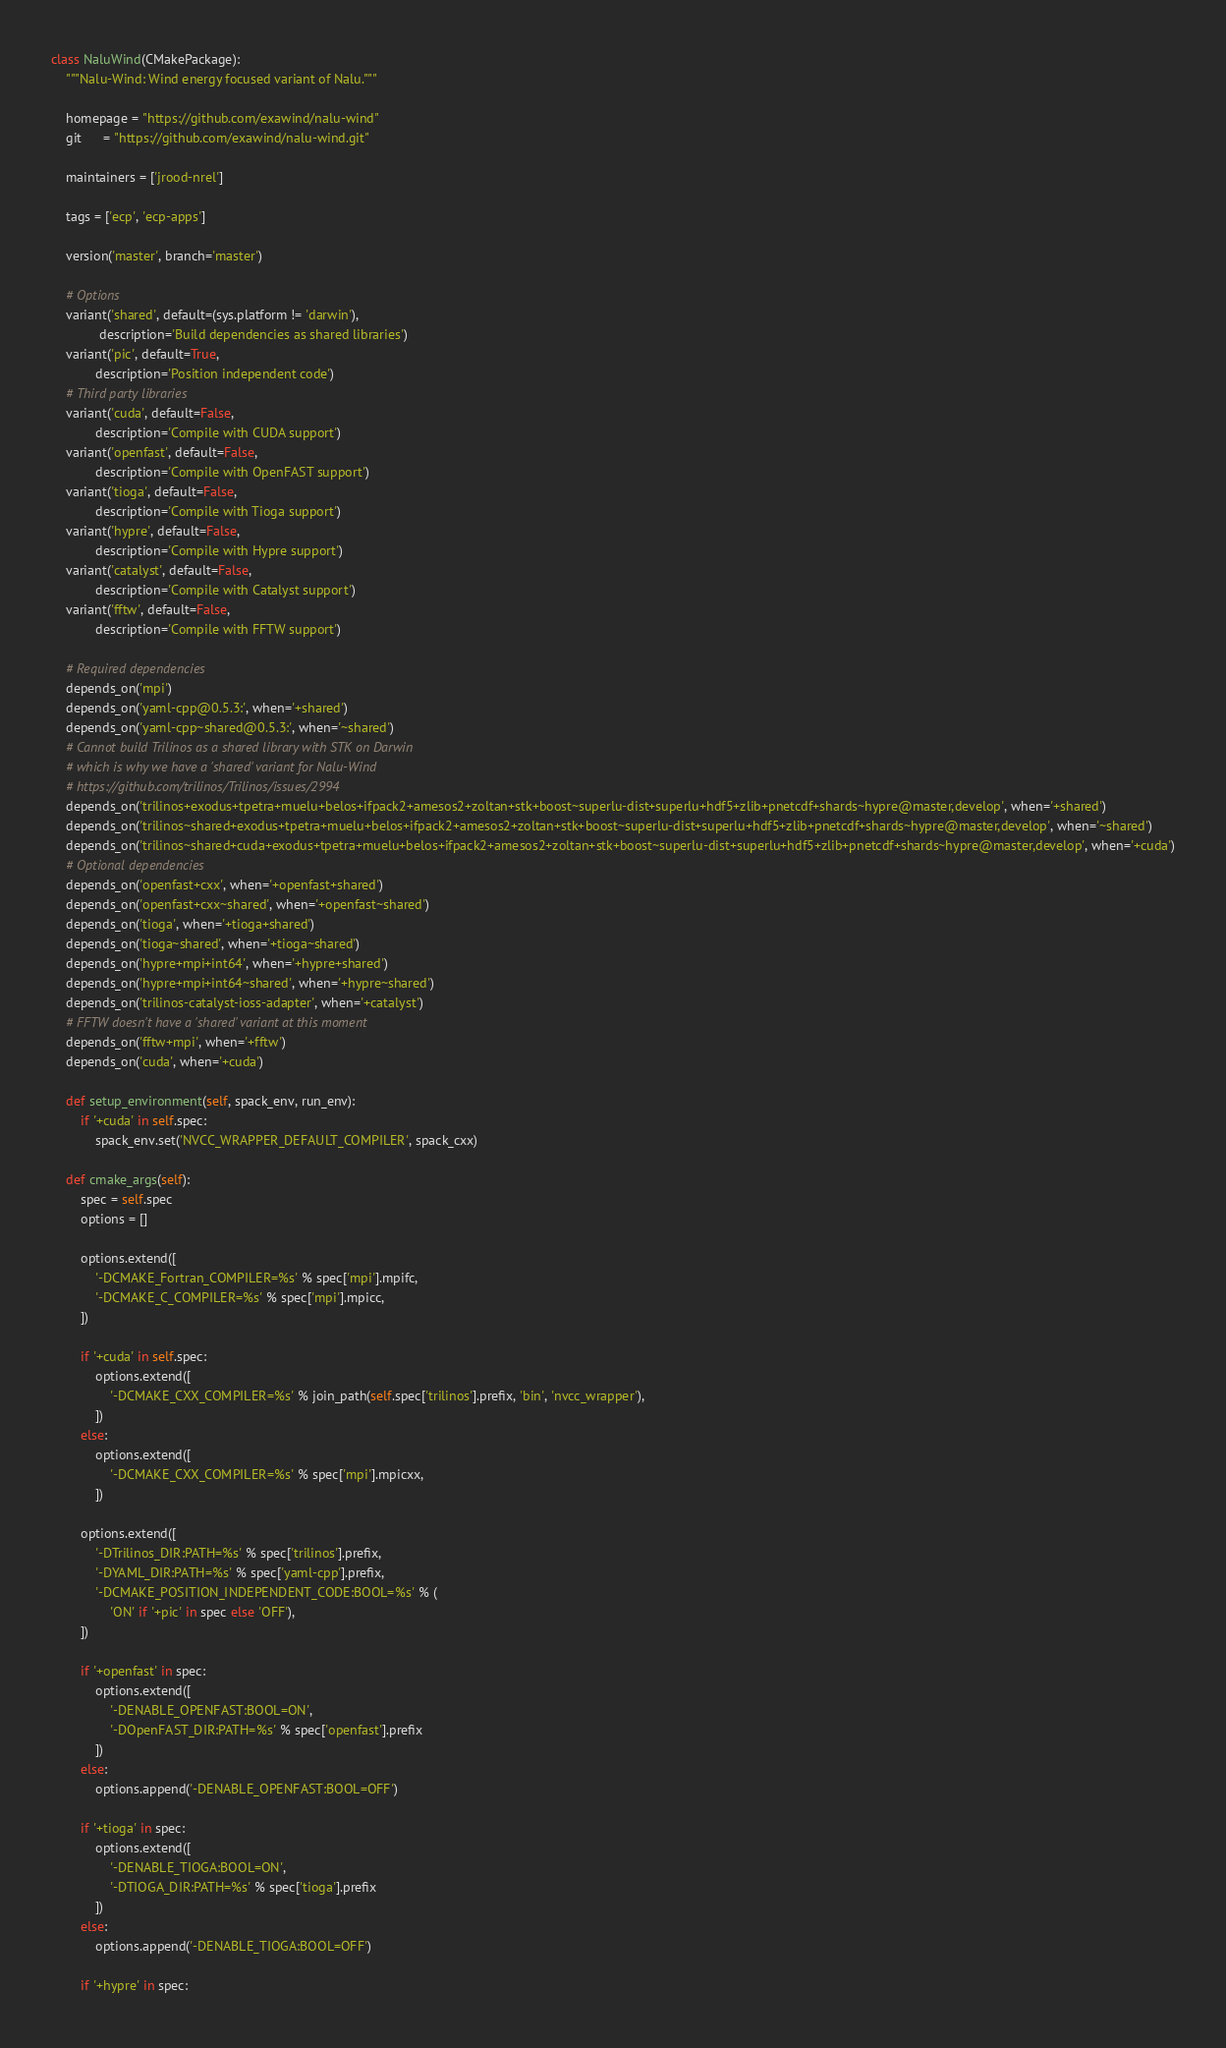<code> <loc_0><loc_0><loc_500><loc_500><_Python_>class NaluWind(CMakePackage):
    """Nalu-Wind: Wind energy focused variant of Nalu."""

    homepage = "https://github.com/exawind/nalu-wind"
    git      = "https://github.com/exawind/nalu-wind.git"

    maintainers = ['jrood-nrel']

    tags = ['ecp', 'ecp-apps']

    version('master', branch='master')

    # Options
    variant('shared', default=(sys.platform != 'darwin'),
             description='Build dependencies as shared libraries')
    variant('pic', default=True,
            description='Position independent code')
    # Third party libraries
    variant('cuda', default=False,
            description='Compile with CUDA support')
    variant('openfast', default=False,
            description='Compile with OpenFAST support')
    variant('tioga', default=False,
            description='Compile with Tioga support')
    variant('hypre', default=False,
            description='Compile with Hypre support')
    variant('catalyst', default=False,
            description='Compile with Catalyst support')
    variant('fftw', default=False,
            description='Compile with FFTW support')

    # Required dependencies
    depends_on('mpi')
    depends_on('yaml-cpp@0.5.3:', when='+shared')
    depends_on('yaml-cpp~shared@0.5.3:', when='~shared')
    # Cannot build Trilinos as a shared library with STK on Darwin
    # which is why we have a 'shared' variant for Nalu-Wind
    # https://github.com/trilinos/Trilinos/issues/2994
    depends_on('trilinos+exodus+tpetra+muelu+belos+ifpack2+amesos2+zoltan+stk+boost~superlu-dist+superlu+hdf5+zlib+pnetcdf+shards~hypre@master,develop', when='+shared')
    depends_on('trilinos~shared+exodus+tpetra+muelu+belos+ifpack2+amesos2+zoltan+stk+boost~superlu-dist+superlu+hdf5+zlib+pnetcdf+shards~hypre@master,develop', when='~shared')
    depends_on('trilinos~shared+cuda+exodus+tpetra+muelu+belos+ifpack2+amesos2+zoltan+stk+boost~superlu-dist+superlu+hdf5+zlib+pnetcdf+shards~hypre@master,develop', when='+cuda')
    # Optional dependencies
    depends_on('openfast+cxx', when='+openfast+shared')
    depends_on('openfast+cxx~shared', when='+openfast~shared')
    depends_on('tioga', when='+tioga+shared')
    depends_on('tioga~shared', when='+tioga~shared')
    depends_on('hypre+mpi+int64', when='+hypre+shared')
    depends_on('hypre+mpi+int64~shared', when='+hypre~shared')
    depends_on('trilinos-catalyst-ioss-adapter', when='+catalyst')
    # FFTW doesn't have a 'shared' variant at this moment
    depends_on('fftw+mpi', when='+fftw')
    depends_on('cuda', when='+cuda')

    def setup_environment(self, spack_env, run_env):
        if '+cuda' in self.spec:
            spack_env.set('NVCC_WRAPPER_DEFAULT_COMPILER', spack_cxx)

    def cmake_args(self):
        spec = self.spec
        options = []

        options.extend([
            '-DCMAKE_Fortran_COMPILER=%s' % spec['mpi'].mpifc,
            '-DCMAKE_C_COMPILER=%s' % spec['mpi'].mpicc,
        ])

        if '+cuda' in self.spec:
            options.extend([
                '-DCMAKE_CXX_COMPILER=%s' % join_path(self.spec['trilinos'].prefix, 'bin', 'nvcc_wrapper'),
            ])
        else:
            options.extend([
                '-DCMAKE_CXX_COMPILER=%s' % spec['mpi'].mpicxx,
            ])

        options.extend([
            '-DTrilinos_DIR:PATH=%s' % spec['trilinos'].prefix,
            '-DYAML_DIR:PATH=%s' % spec['yaml-cpp'].prefix,
            '-DCMAKE_POSITION_INDEPENDENT_CODE:BOOL=%s' % (
                'ON' if '+pic' in spec else 'OFF'),
        ])

        if '+openfast' in spec:
            options.extend([
                '-DENABLE_OPENFAST:BOOL=ON',
                '-DOpenFAST_DIR:PATH=%s' % spec['openfast'].prefix
            ])
        else:
            options.append('-DENABLE_OPENFAST:BOOL=OFF')

        if '+tioga' in spec:
            options.extend([
                '-DENABLE_TIOGA:BOOL=ON',
                '-DTIOGA_DIR:PATH=%s' % spec['tioga'].prefix
            ])
        else:
            options.append('-DENABLE_TIOGA:BOOL=OFF')

        if '+hypre' in spec:</code> 